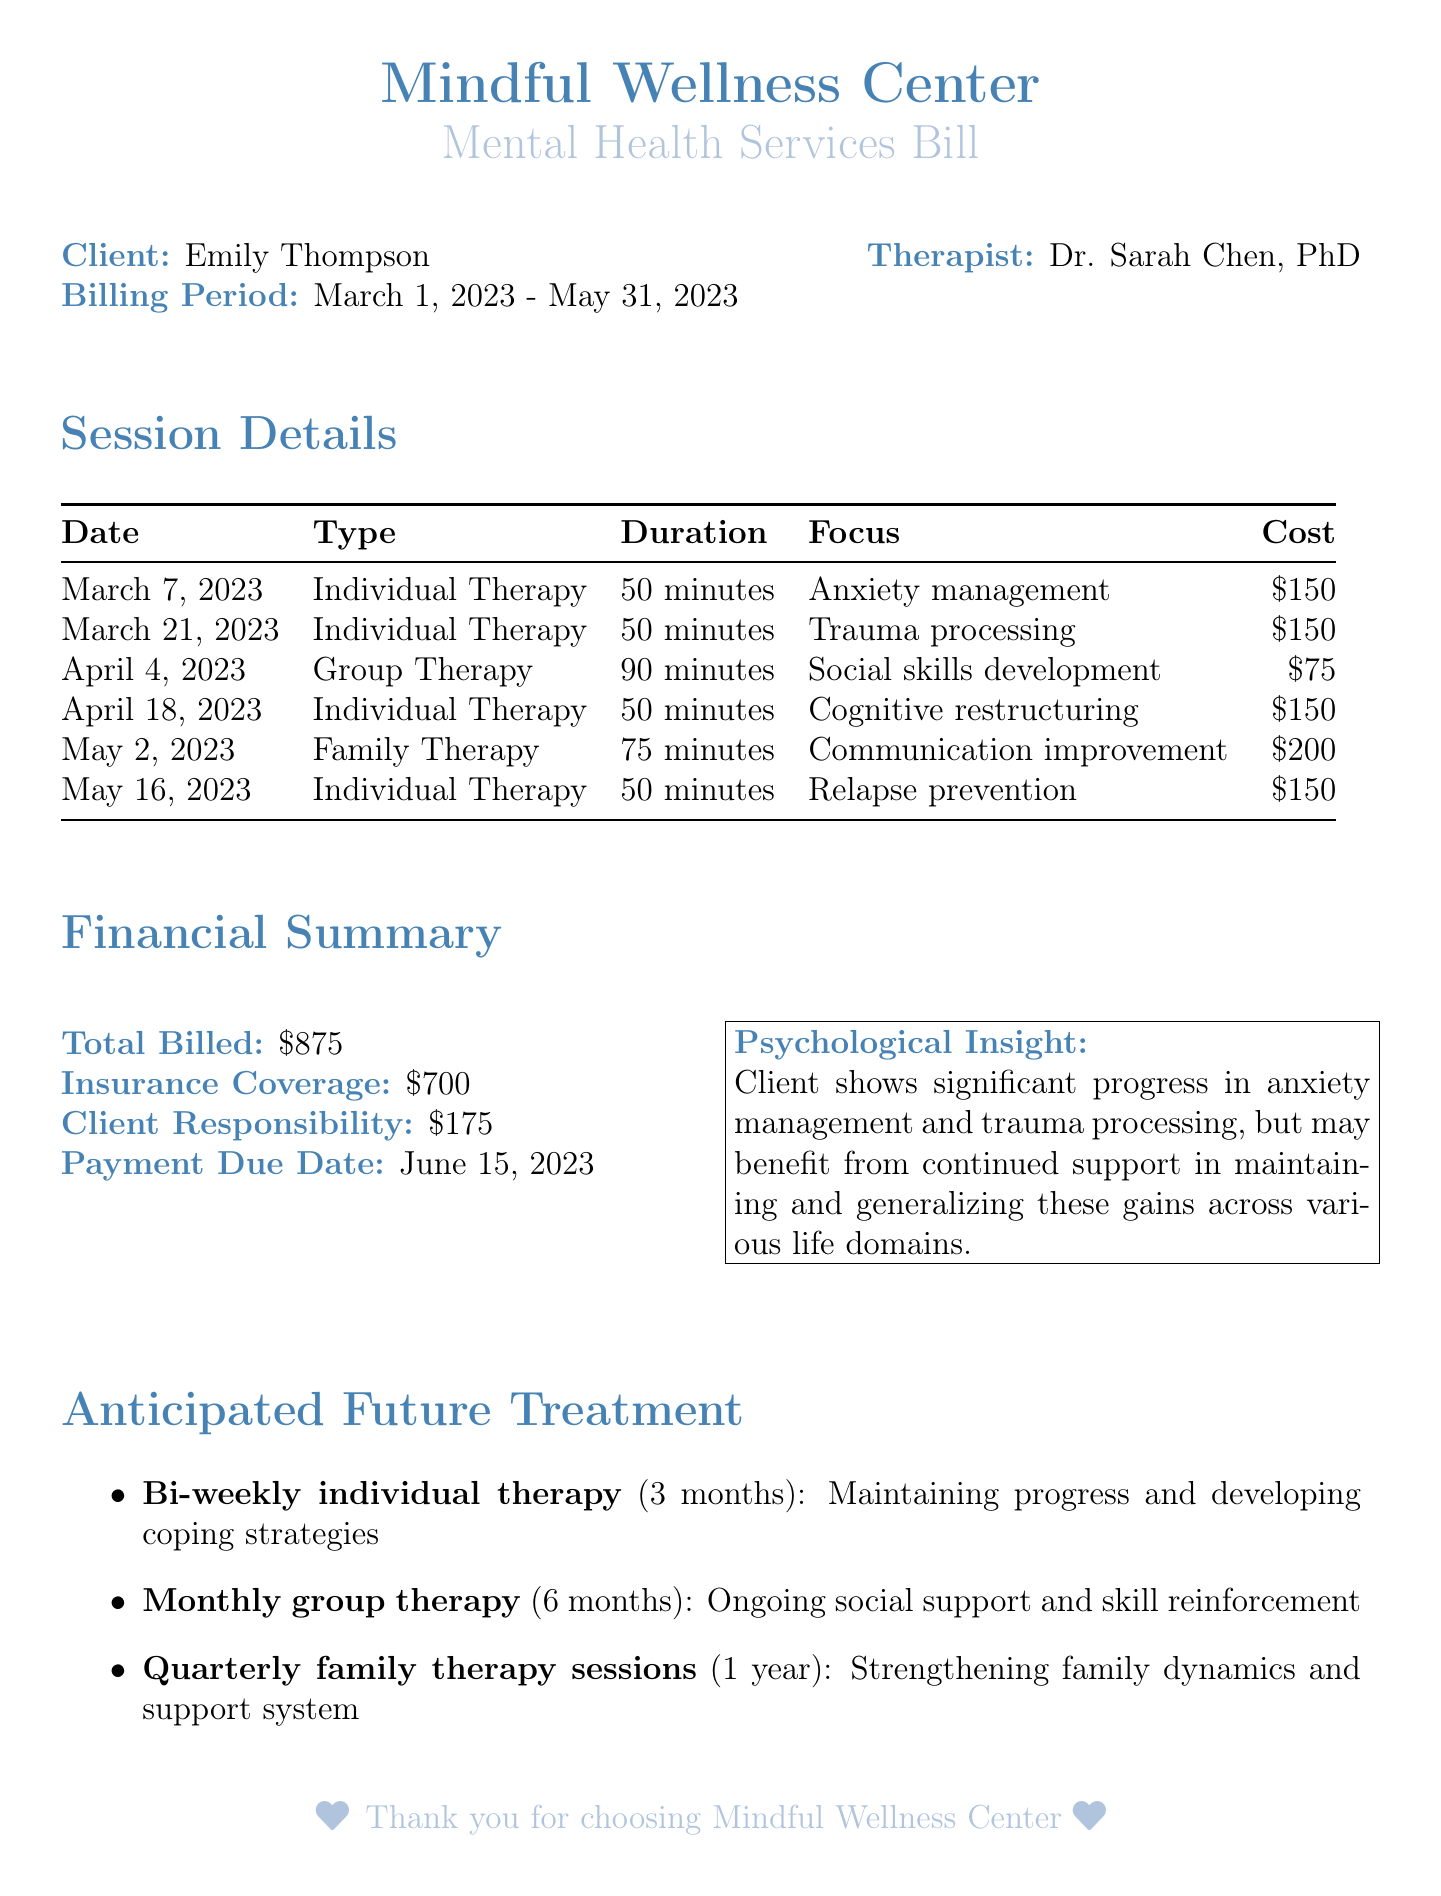What is the client's name? The client's name is listed at the top of the document.
Answer: Emily Thompson Who is the therapist? The therapist's name is provided alongside the client's details.
Answer: Dr. Sarah Chen, PhD What is the total billed amount? The total billed amount is summarized in the financial section of the document.
Answer: $875 How many individual therapy sessions were scheduled? The document outlines each session, allowing for a count of individual therapy sessions specifically.
Answer: 4 What is the client responsibility after insurance coverage? The financial summary lists the client responsibility after deducting insurance coverage.
Answer: $175 What was the focus of the family therapy session? The focus of the family therapy session is specified in the session details table.
Answer: Communication improvement What is the anticipated frequency of individual therapy sessions in the future? The document describes future treatment needs and their expected frequency.
Answer: Bi-weekly How long is the anticipated duration for monthly group therapy? The future treatment section indicates the duration for the group therapy sessions.
Answer: 6 months What is the total insurance coverage for this billing period? The document outlines the insurance coverage within the financial summary.
Answer: $700 